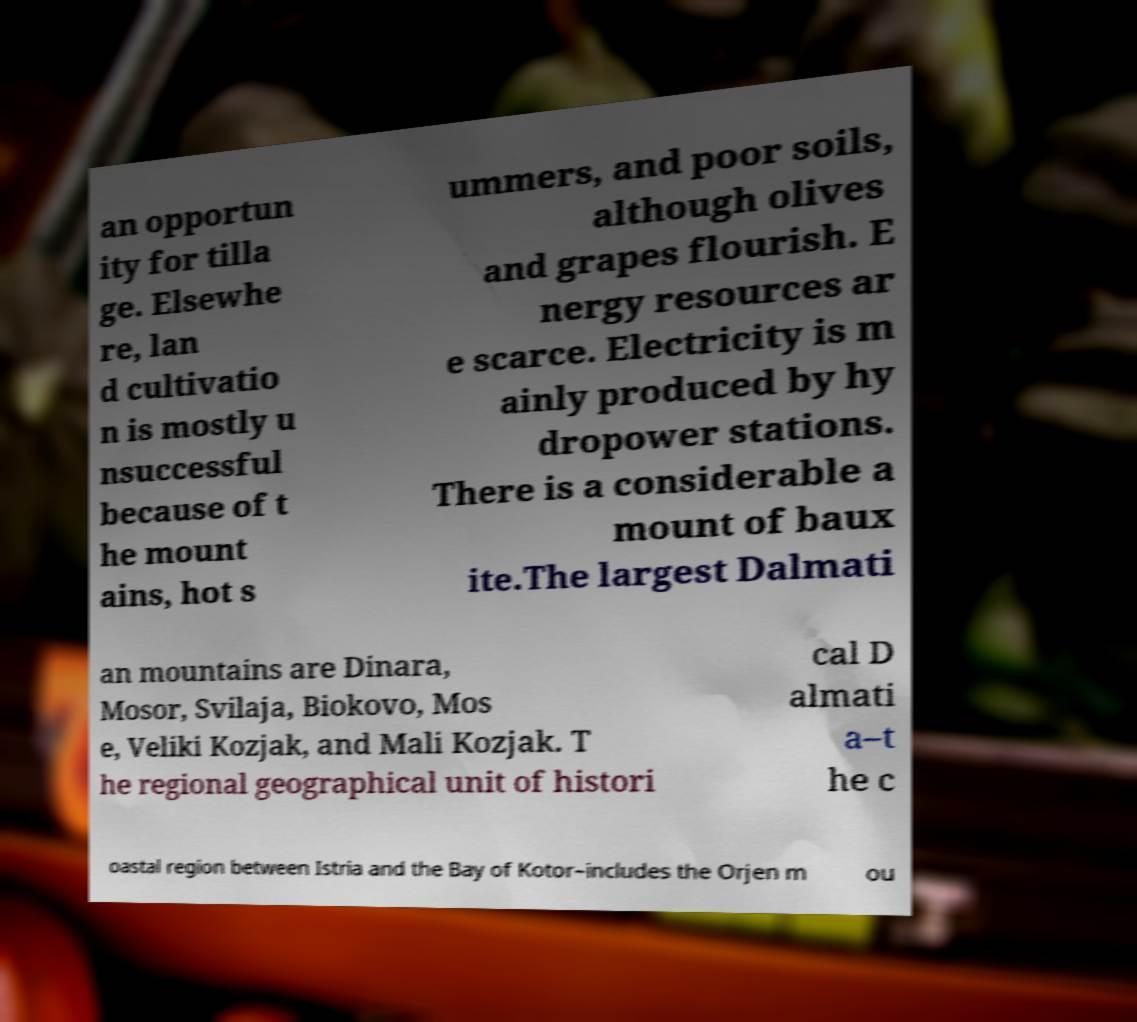Could you assist in decoding the text presented in this image and type it out clearly? an opportun ity for tilla ge. Elsewhe re, lan d cultivatio n is mostly u nsuccessful because of t he mount ains, hot s ummers, and poor soils, although olives and grapes flourish. E nergy resources ar e scarce. Electricity is m ainly produced by hy dropower stations. There is a considerable a mount of baux ite.The largest Dalmati an mountains are Dinara, Mosor, Svilaja, Biokovo, Mos e, Veliki Kozjak, and Mali Kozjak. T he regional geographical unit of histori cal D almati a–t he c oastal region between Istria and the Bay of Kotor–includes the Orjen m ou 